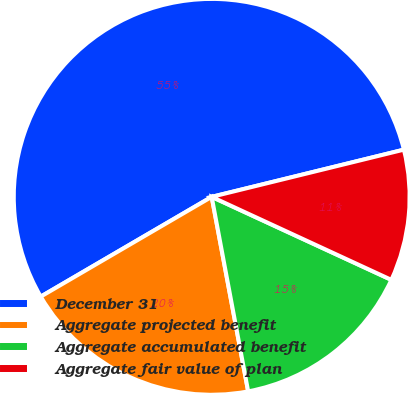Convert chart to OTSL. <chart><loc_0><loc_0><loc_500><loc_500><pie_chart><fcel>December 31<fcel>Aggregate projected benefit<fcel>Aggregate accumulated benefit<fcel>Aggregate fair value of plan<nl><fcel>54.57%<fcel>19.54%<fcel>15.16%<fcel>10.72%<nl></chart> 